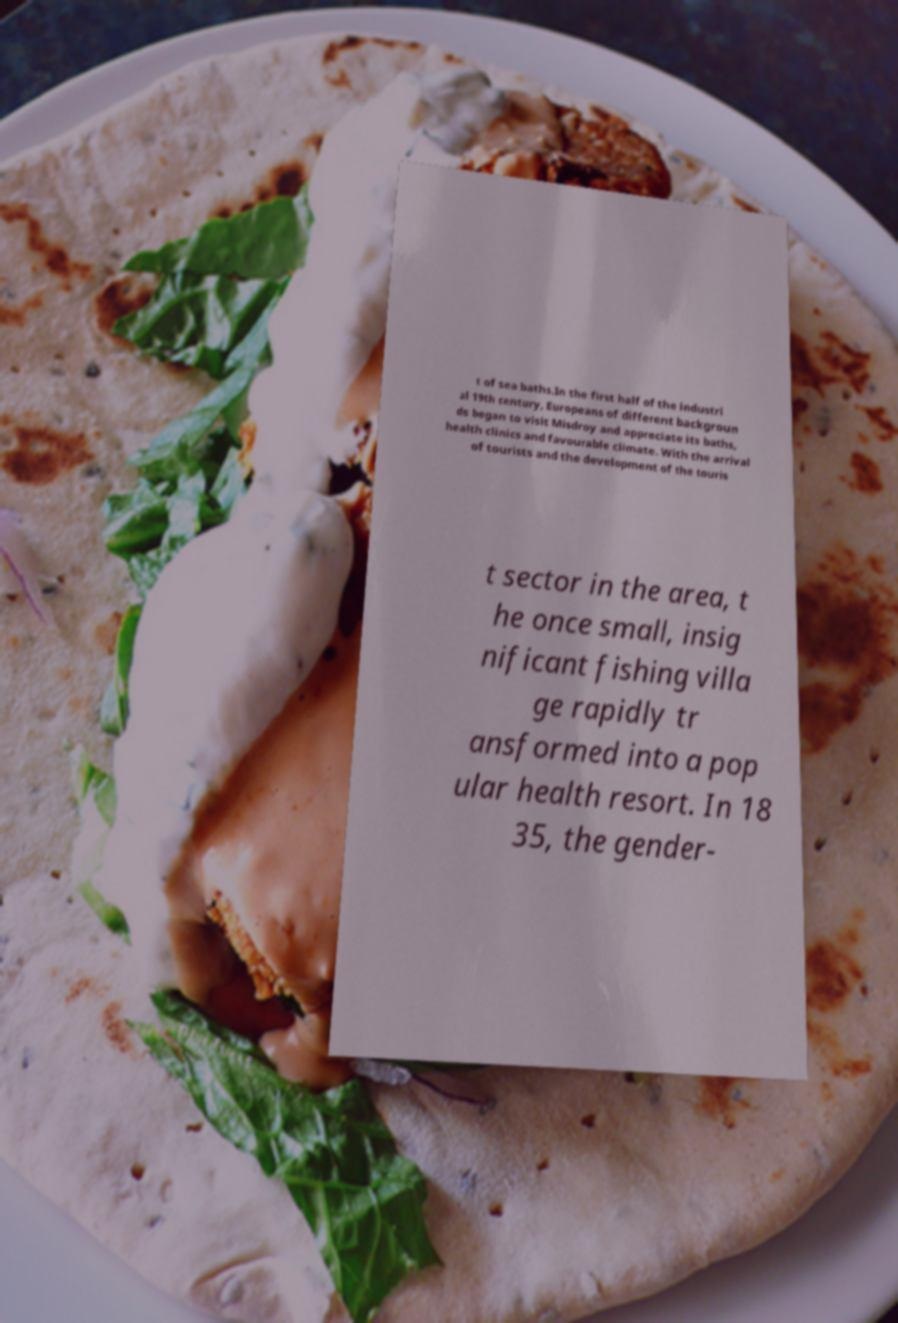Could you assist in decoding the text presented in this image and type it out clearly? t of sea baths.In the first half of the industri al 19th century, Europeans of different backgroun ds began to visit Misdroy and appreciate its baths, health clinics and favourable climate. With the arrival of tourists and the development of the touris t sector in the area, t he once small, insig nificant fishing villa ge rapidly tr ansformed into a pop ular health resort. In 18 35, the gender- 